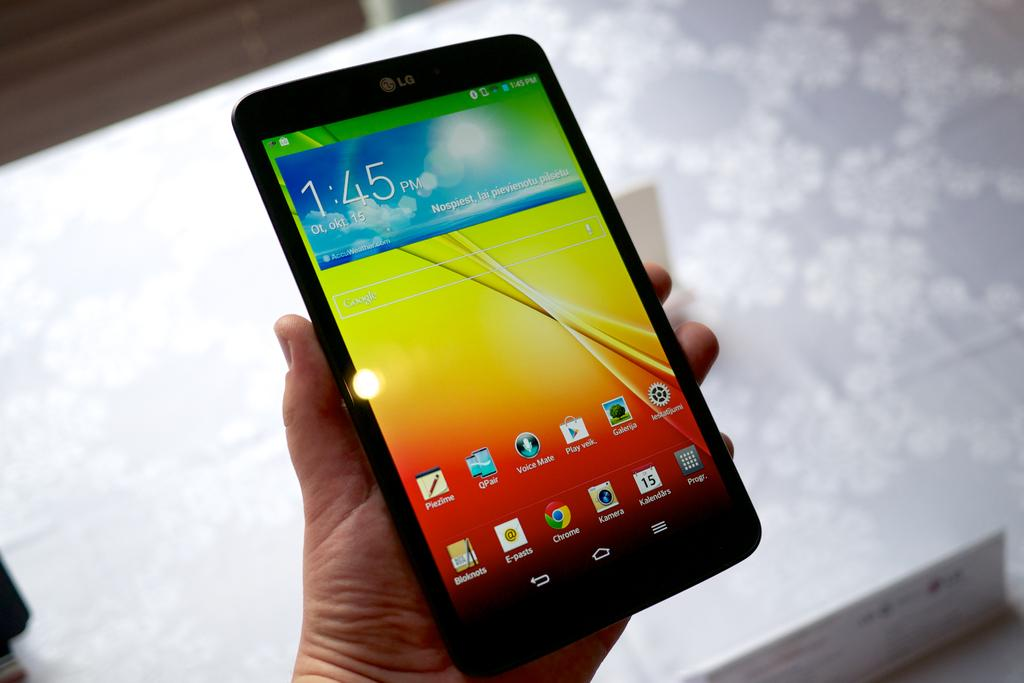What part of the human body is visible in the image? There is a human hand in the image. What is the hand holding? The hand is holding a tab. How many boys can be observed playing in the background of the image? There are no boys present in the image; it only features a human hand holding a tab. 